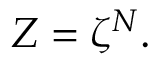<formula> <loc_0><loc_0><loc_500><loc_500>Z = \zeta ^ { N } .</formula> 